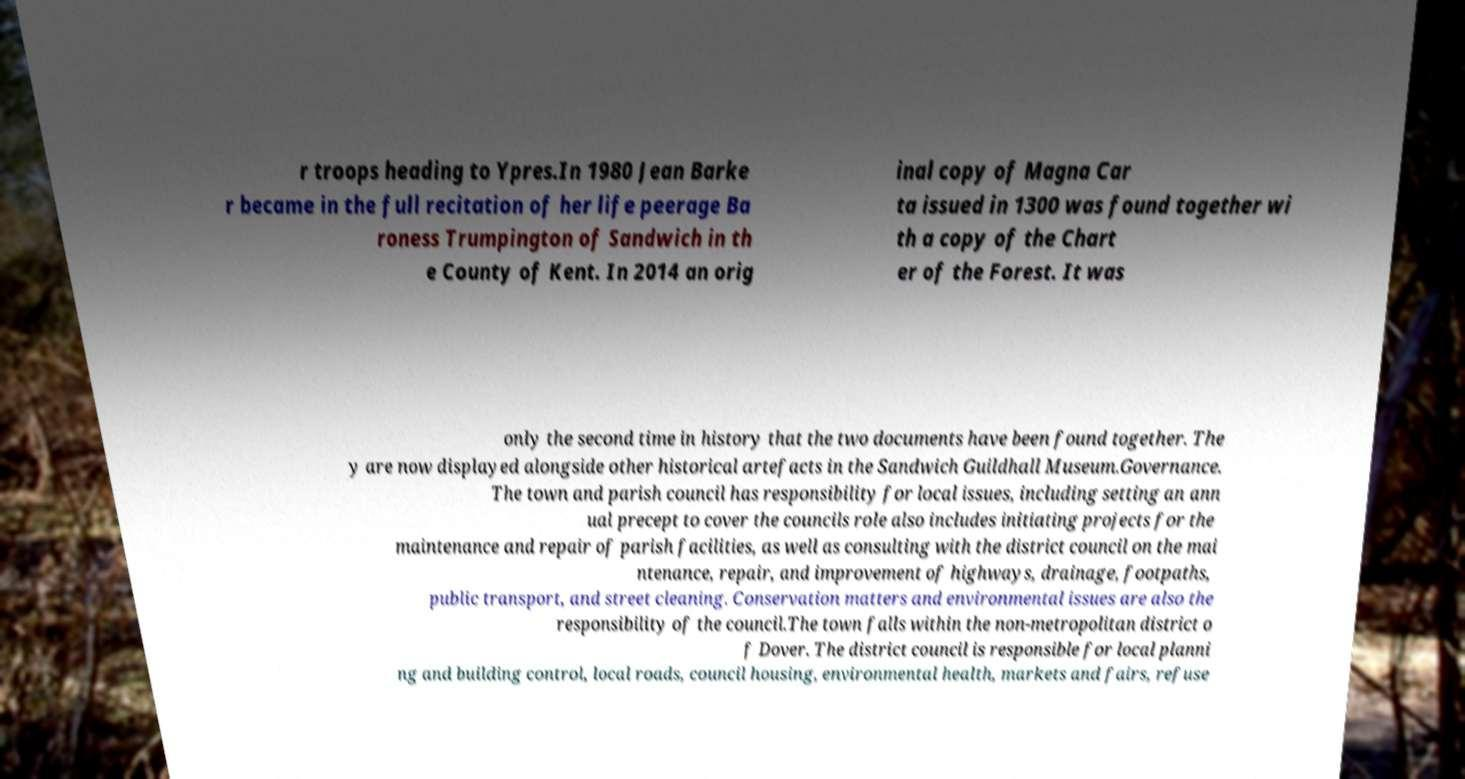Please identify and transcribe the text found in this image. r troops heading to Ypres.In 1980 Jean Barke r became in the full recitation of her life peerage Ba roness Trumpington of Sandwich in th e County of Kent. In 2014 an orig inal copy of Magna Car ta issued in 1300 was found together wi th a copy of the Chart er of the Forest. It was only the second time in history that the two documents have been found together. The y are now displayed alongside other historical artefacts in the Sandwich Guildhall Museum.Governance. The town and parish council has responsibility for local issues, including setting an ann ual precept to cover the councils role also includes initiating projects for the maintenance and repair of parish facilities, as well as consulting with the district council on the mai ntenance, repair, and improvement of highways, drainage, footpaths, public transport, and street cleaning. Conservation matters and environmental issues are also the responsibility of the council.The town falls within the non-metropolitan district o f Dover. The district council is responsible for local planni ng and building control, local roads, council housing, environmental health, markets and fairs, refuse 